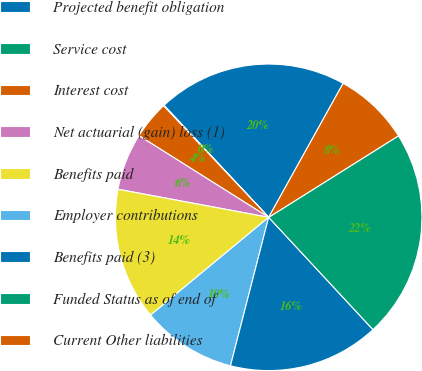<chart> <loc_0><loc_0><loc_500><loc_500><pie_chart><fcel>Projected benefit obligation<fcel>Service cost<fcel>Interest cost<fcel>Net actuarial (gain) loss (1)<fcel>Benefits paid<fcel>Employer contributions<fcel>Benefits paid (3)<fcel>Funded Status as of end of<fcel>Current Other liabilities<nl><fcel>20.03%<fcel>0.07%<fcel>4.03%<fcel>6.01%<fcel>13.94%<fcel>9.98%<fcel>15.92%<fcel>22.01%<fcel>8.0%<nl></chart> 